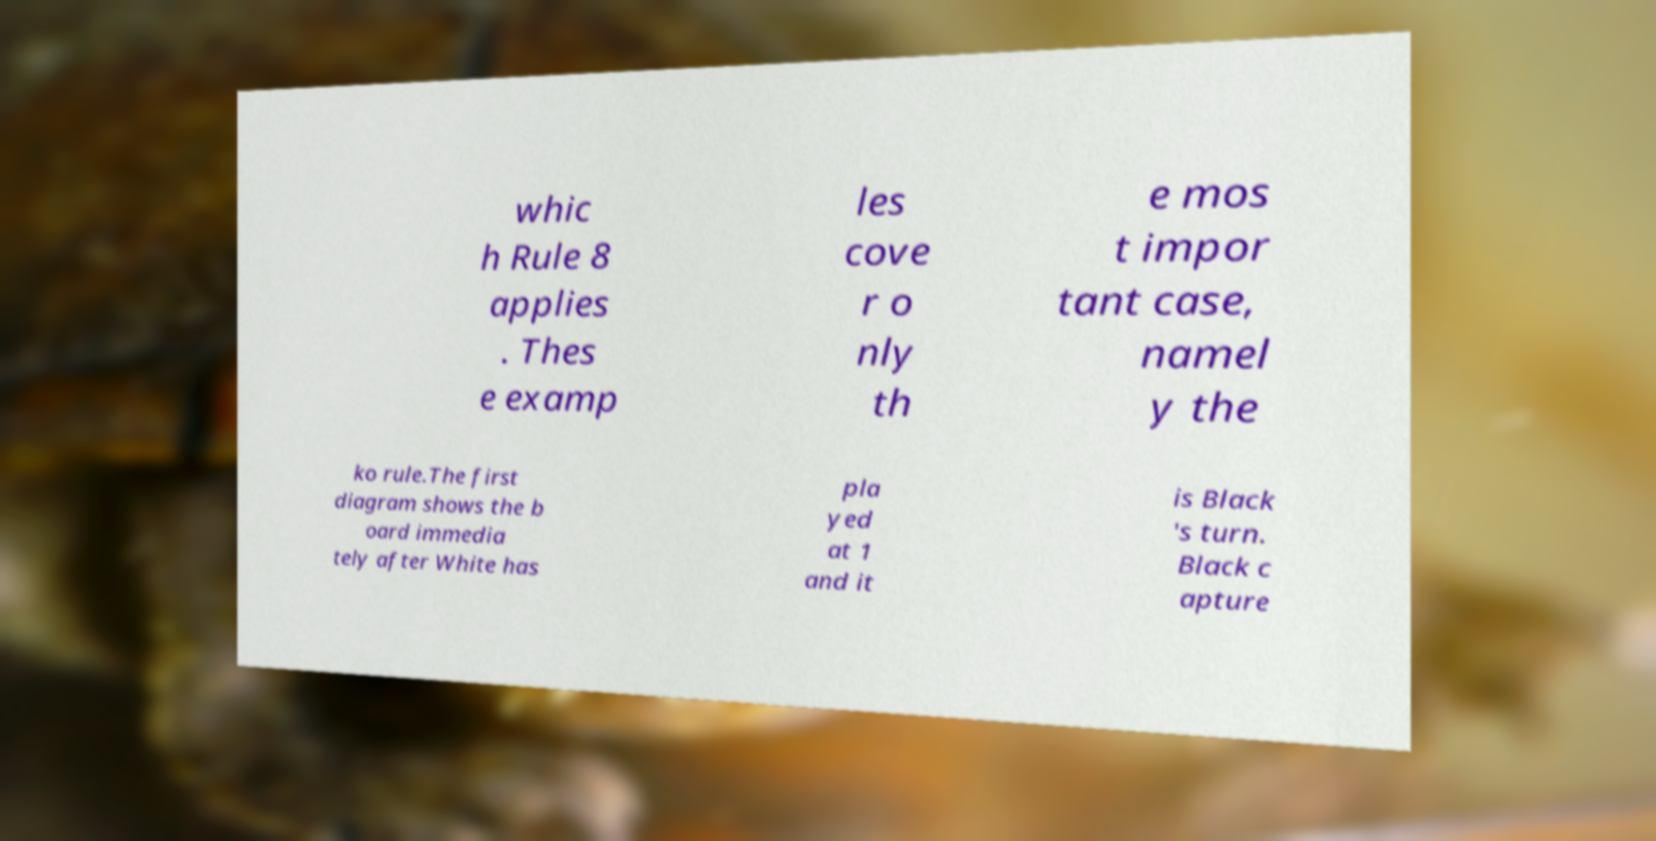Please read and relay the text visible in this image. What does it say? whic h Rule 8 applies . Thes e examp les cove r o nly th e mos t impor tant case, namel y the ko rule.The first diagram shows the b oard immedia tely after White has pla yed at 1 and it is Black 's turn. Black c apture 